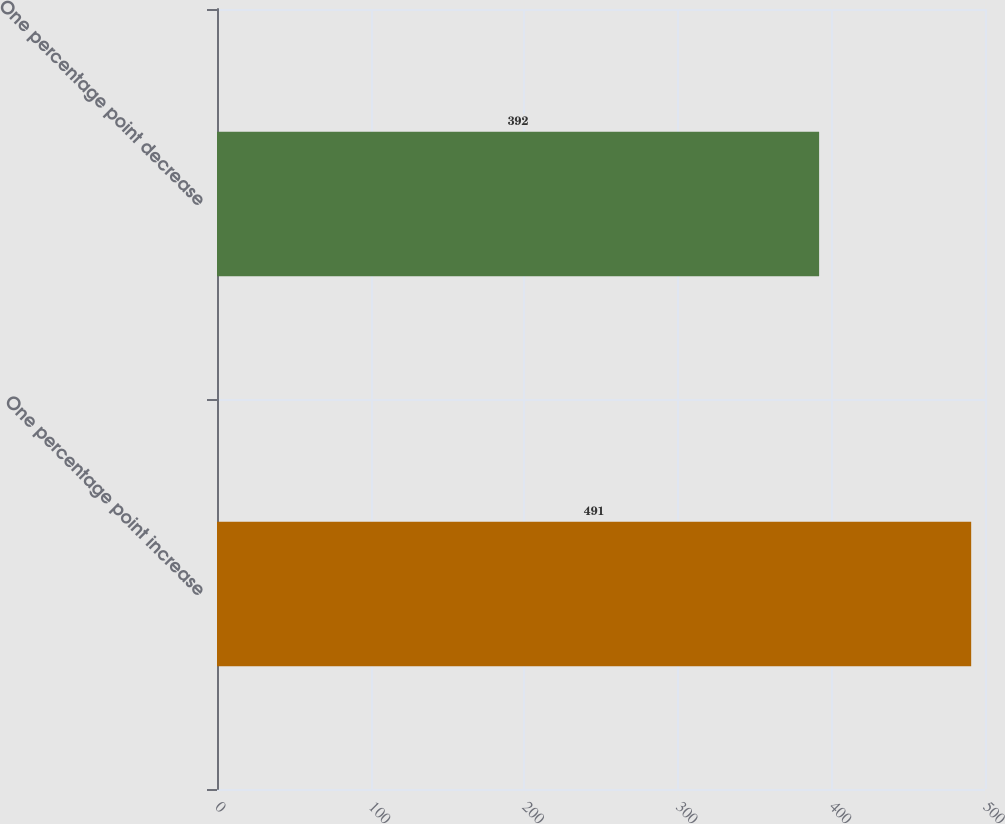<chart> <loc_0><loc_0><loc_500><loc_500><bar_chart><fcel>One percentage point increase<fcel>One percentage point decrease<nl><fcel>491<fcel>392<nl></chart> 